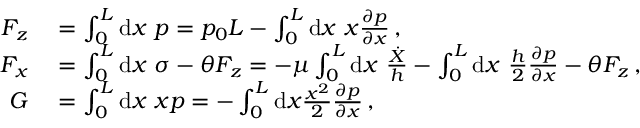Convert formula to latex. <formula><loc_0><loc_0><loc_500><loc_500>\begin{array} { r l } { F _ { z } } & = \int _ { 0 } ^ { L } d x \ p = p _ { 0 } L - \int _ { 0 } ^ { L } d x \ x \frac { \partial p } { \partial x } \, , } \\ { F _ { x } } & = \int _ { 0 } ^ { L } d x \ \sigma - \theta F _ { z } = - \mu \int _ { 0 } ^ { L } d x \ \frac { \dot { X } } { h } - \int _ { 0 } ^ { L } d x \ \frac { h } { 2 } \frac { \partial p } { \partial x } - \theta F _ { z } \, , } \\ { G } & = \int _ { 0 } ^ { L } d x \ x p = - \int _ { 0 } ^ { L } d x \frac { x ^ { 2 } } { 2 } \frac { \partial p } { \partial x } \, , } \end{array}</formula> 